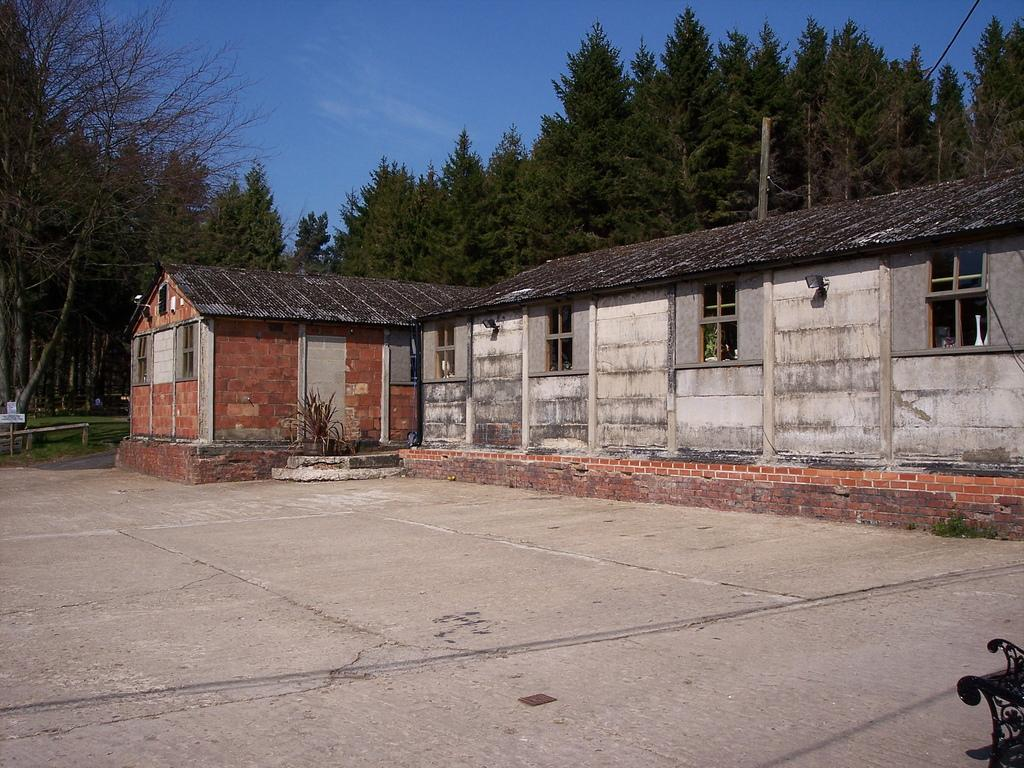What type of structure is present in the image? There is a building in the image. What other natural elements can be seen in the image? There are house plants and trees in the image. What is visible in the background of the image? The sky is visible in the image, and there are clouds in the sky. What type of pancake is being served on the side in the image? There is no pancake present in the image; it only features a building, house plants, trees, and the sky. 